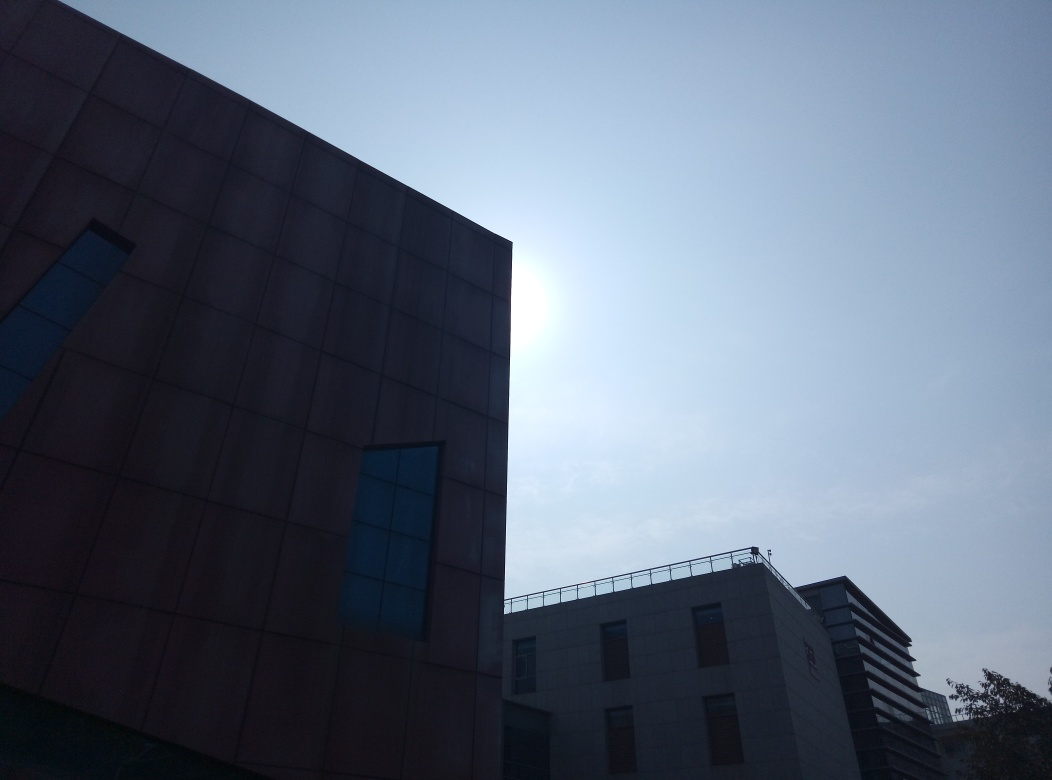Is the image properly focused? Upon review, the image appears to be partially focused. The building in the foreground is reasonably sharp, but the image overall has a soft quality, likely due to the strong backlight from the sun, which can reduce the perceived sharpness and detail in the scene. 